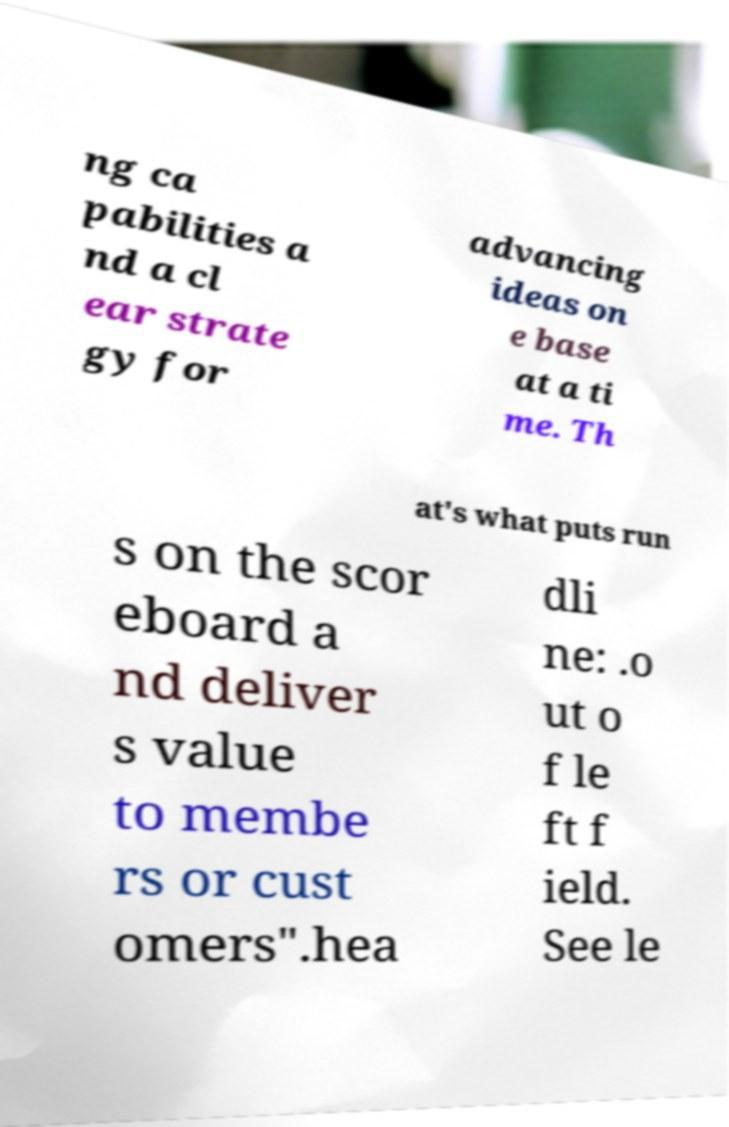Please read and relay the text visible in this image. What does it say? ng ca pabilities a nd a cl ear strate gy for advancing ideas on e base at a ti me. Th at's what puts run s on the scor eboard a nd deliver s value to membe rs or cust omers".hea dli ne: .o ut o f le ft f ield. See le 